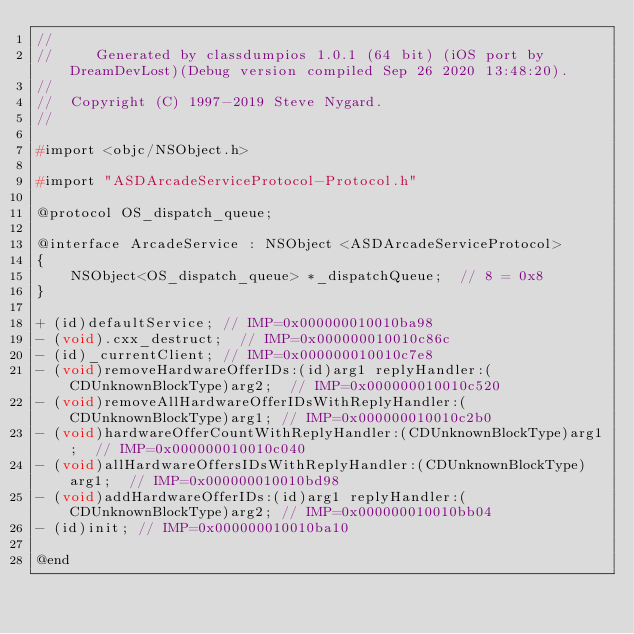<code> <loc_0><loc_0><loc_500><loc_500><_C_>//
//     Generated by classdumpios 1.0.1 (64 bit) (iOS port by DreamDevLost)(Debug version compiled Sep 26 2020 13:48:20).
//
//  Copyright (C) 1997-2019 Steve Nygard.
//

#import <objc/NSObject.h>

#import "ASDArcadeServiceProtocol-Protocol.h"

@protocol OS_dispatch_queue;

@interface ArcadeService : NSObject <ASDArcadeServiceProtocol>
{
    NSObject<OS_dispatch_queue> *_dispatchQueue;	// 8 = 0x8
}

+ (id)defaultService;	// IMP=0x000000010010ba98
- (void).cxx_destruct;	// IMP=0x000000010010c86c
- (id)_currentClient;	// IMP=0x000000010010c7e8
- (void)removeHardwareOfferIDs:(id)arg1 replyHandler:(CDUnknownBlockType)arg2;	// IMP=0x000000010010c520
- (void)removeAllHardwareOfferIDsWithReplyHandler:(CDUnknownBlockType)arg1;	// IMP=0x000000010010c2b0
- (void)hardwareOfferCountWithReplyHandler:(CDUnknownBlockType)arg1;	// IMP=0x000000010010c040
- (void)allHardwareOffersIDsWithReplyHandler:(CDUnknownBlockType)arg1;	// IMP=0x000000010010bd98
- (void)addHardwareOfferIDs:(id)arg1 replyHandler:(CDUnknownBlockType)arg2;	// IMP=0x000000010010bb04
- (id)init;	// IMP=0x000000010010ba10

@end

</code> 